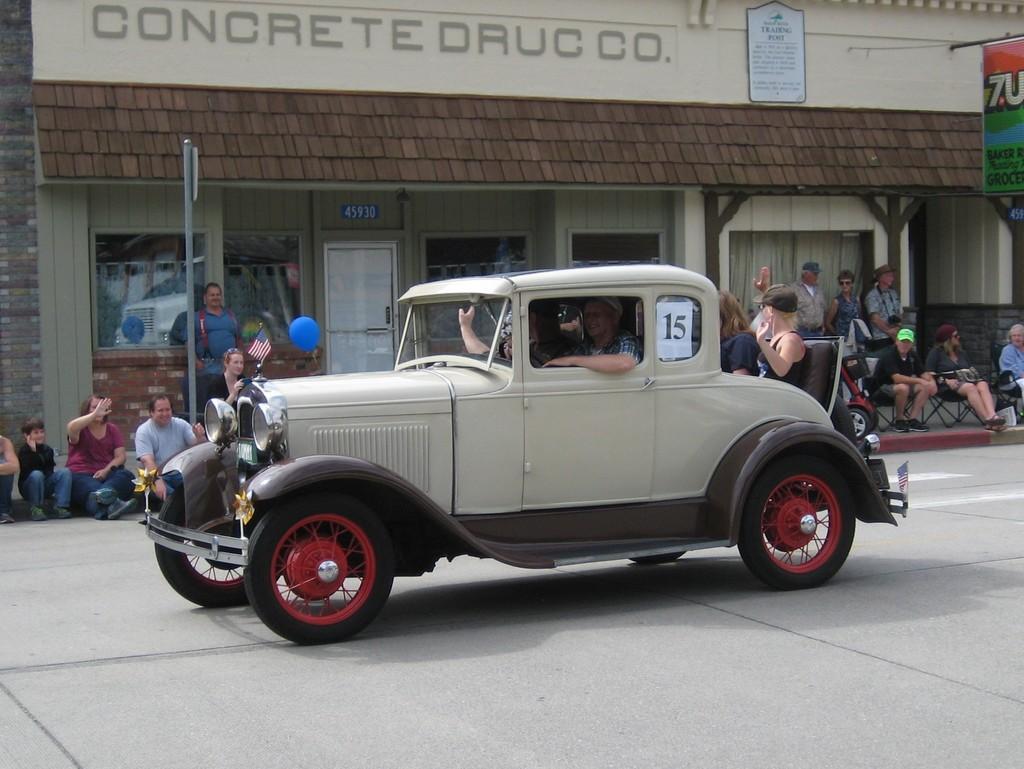Can you describe this image briefly? In this image in the center there is one vehicle and some persons are sitting in a vehicle, in the background there are a group of people who are sitting and also there is a building, pole, boards. At the bottom there is a walkway. 